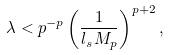<formula> <loc_0><loc_0><loc_500><loc_500>\lambda < p ^ { - p } \left ( \frac { 1 } { l _ { s } M _ { p } } \right ) ^ { p + 2 } ,</formula> 